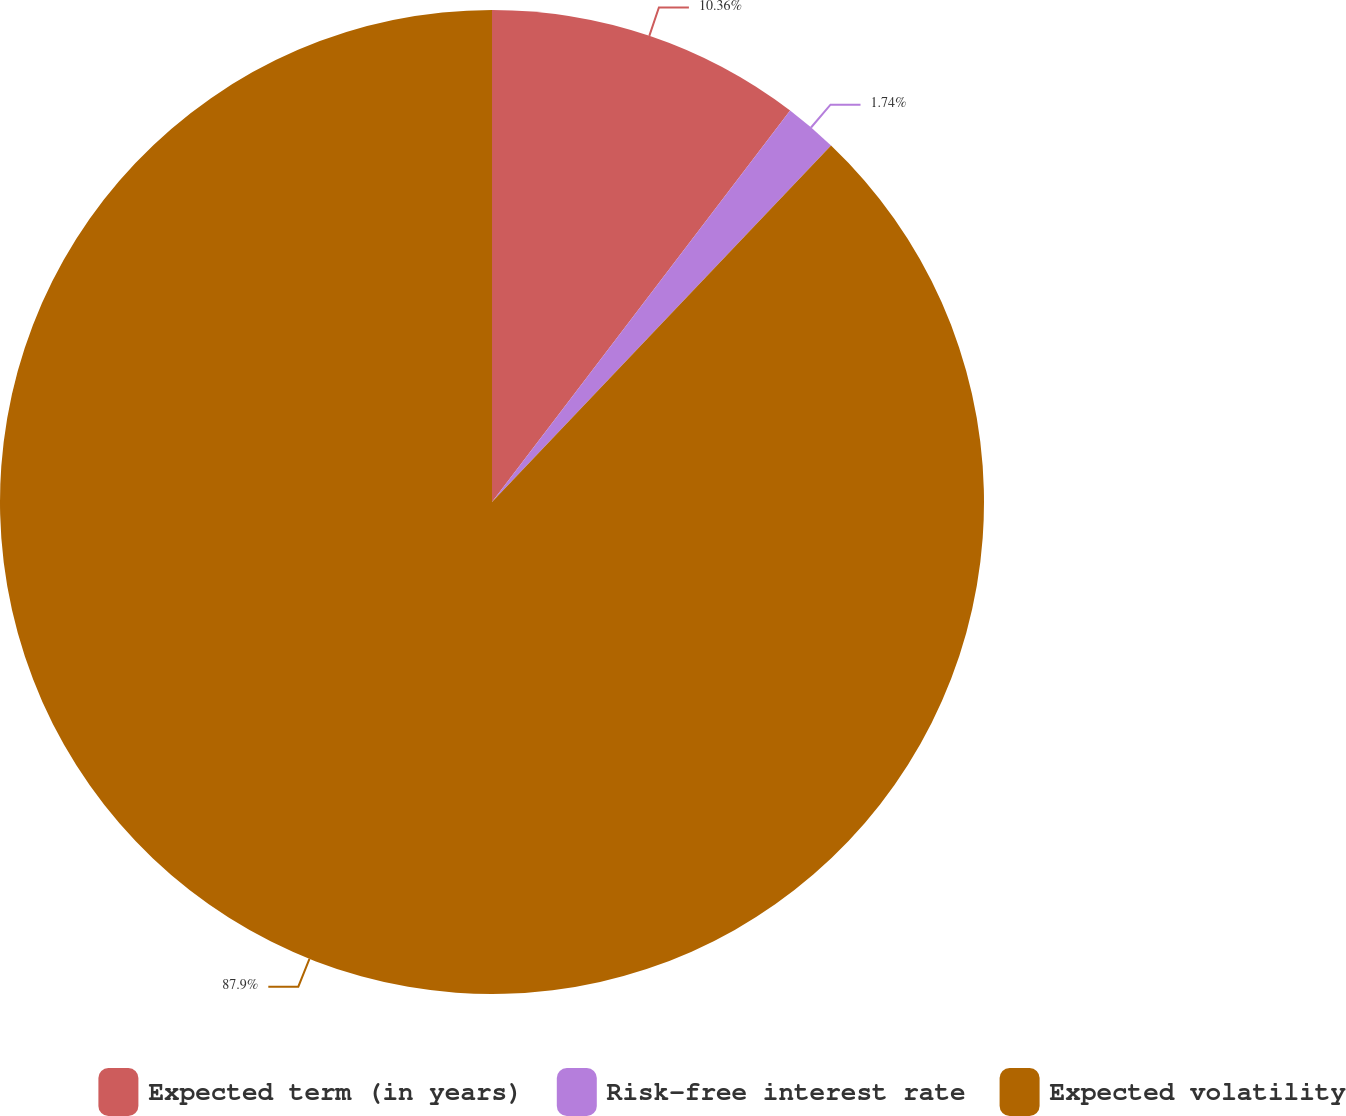Convert chart to OTSL. <chart><loc_0><loc_0><loc_500><loc_500><pie_chart><fcel>Expected term (in years)<fcel>Risk-free interest rate<fcel>Expected volatility<nl><fcel>10.36%<fcel>1.74%<fcel>87.9%<nl></chart> 